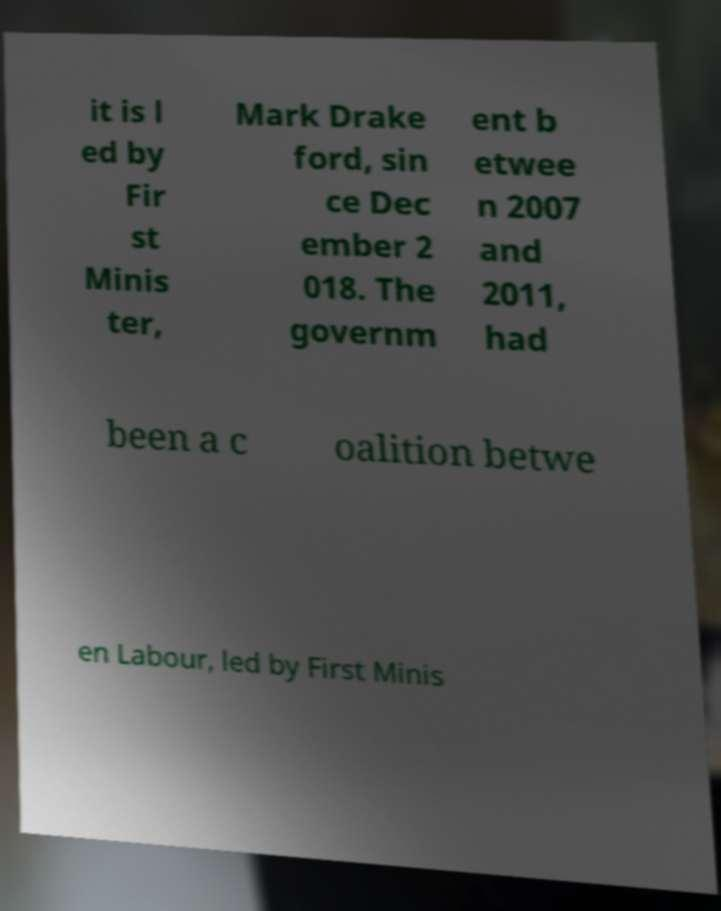Can you read and provide the text displayed in the image?This photo seems to have some interesting text. Can you extract and type it out for me? it is l ed by Fir st Minis ter, Mark Drake ford, sin ce Dec ember 2 018. The governm ent b etwee n 2007 and 2011, had been a c oalition betwe en Labour, led by First Minis 